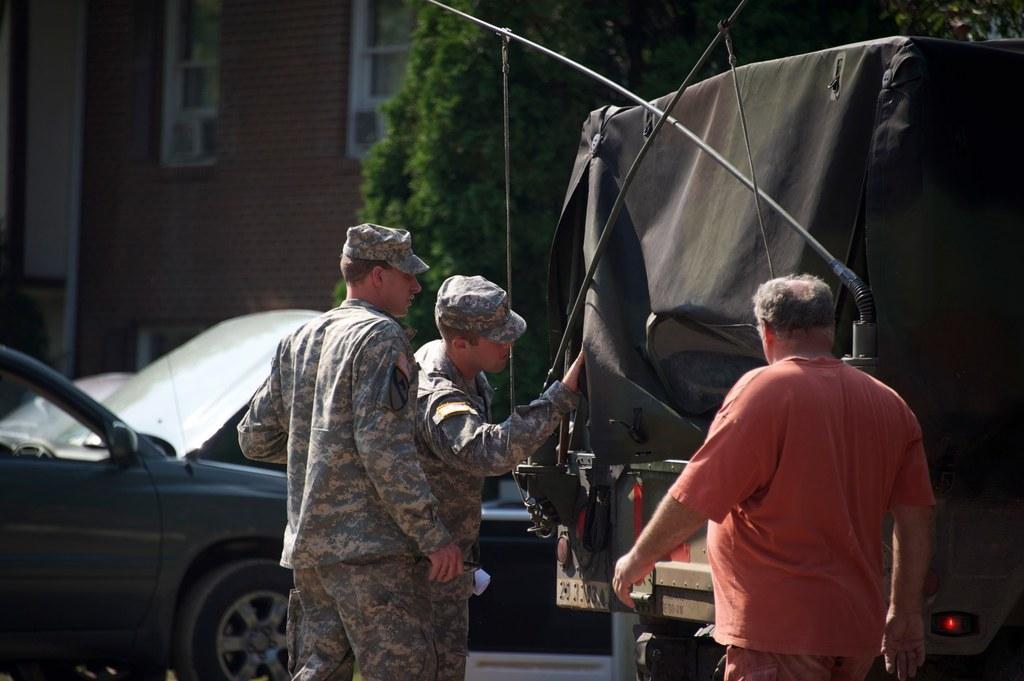Could you give a brief overview of what you see in this image? In this picture I can see three persons standing, there are vehicles, there are trees, there is a building with windows. 